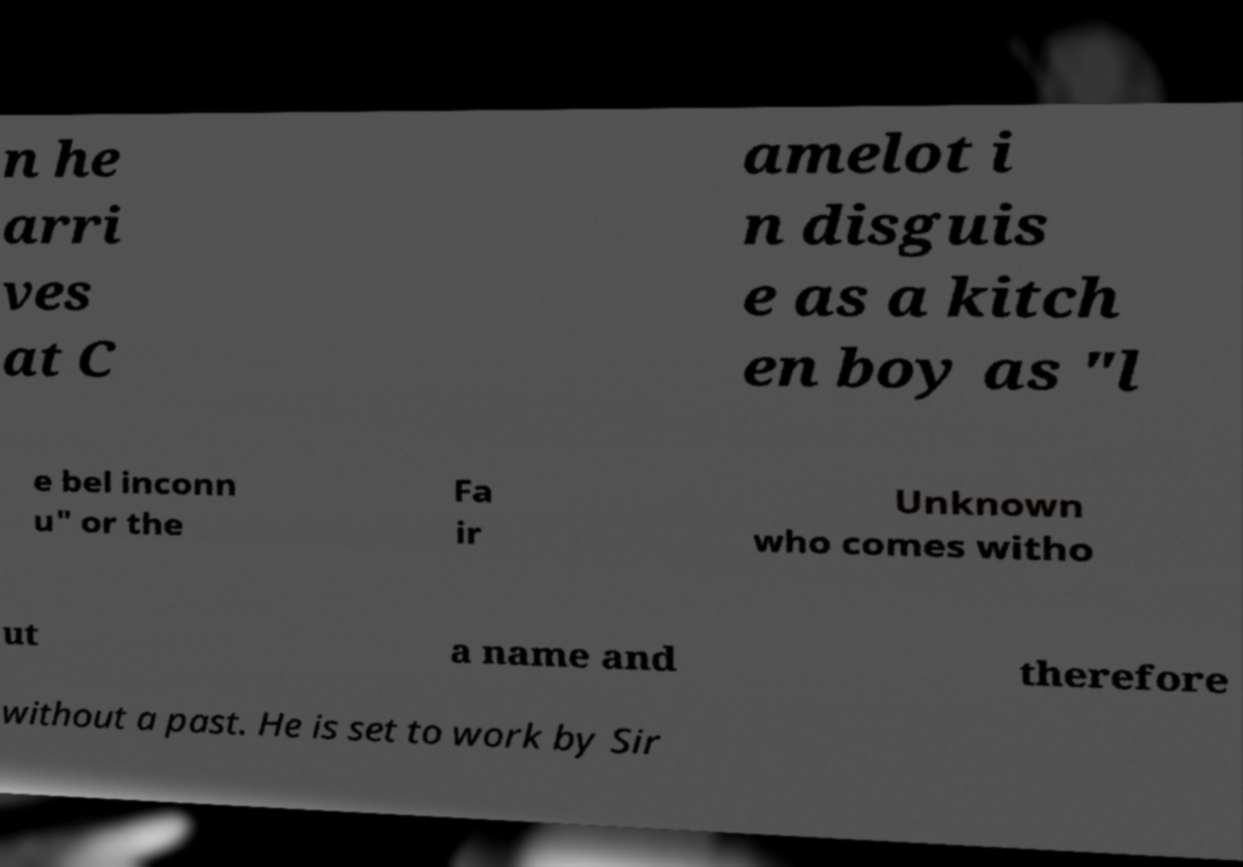Could you extract and type out the text from this image? n he arri ves at C amelot i n disguis e as a kitch en boy as "l e bel inconn u" or the Fa ir Unknown who comes witho ut a name and therefore without a past. He is set to work by Sir 